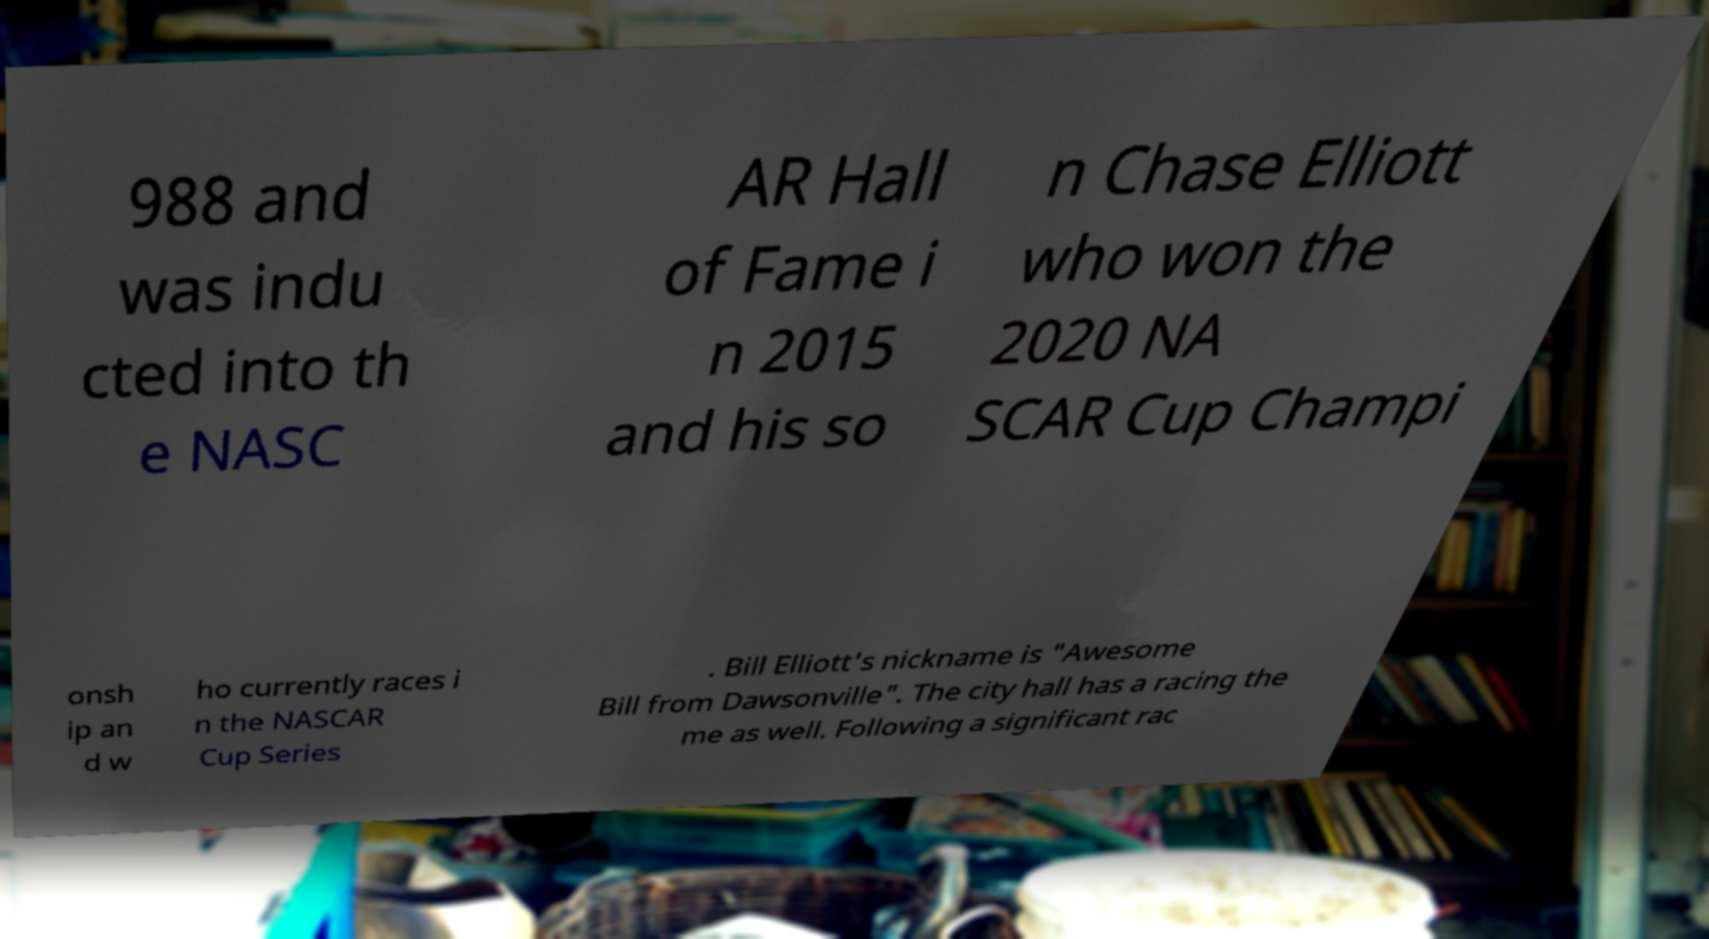Please identify and transcribe the text found in this image. 988 and was indu cted into th e NASC AR Hall of Fame i n 2015 and his so n Chase Elliott who won the 2020 NA SCAR Cup Champi onsh ip an d w ho currently races i n the NASCAR Cup Series . Bill Elliott's nickname is "Awesome Bill from Dawsonville". The city hall has a racing the me as well. Following a significant rac 